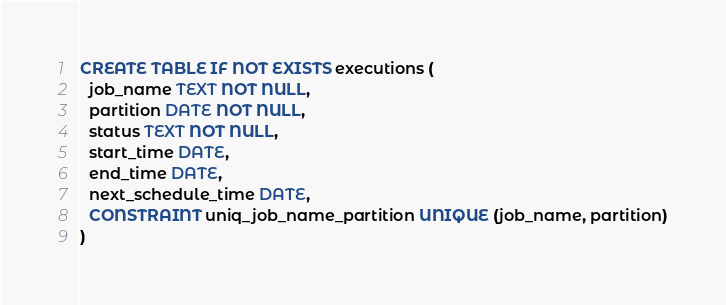Convert code to text. <code><loc_0><loc_0><loc_500><loc_500><_SQL_>CREATE TABLE IF NOT EXISTS executions (
  job_name TEXT NOT NULL,
  partition DATE NOT NULL,
  status TEXT NOT NULL,
  start_time DATE,
  end_time DATE,
  next_schedule_time DATE,
  CONSTRAINT uniq_job_name_partition UNIQUE (job_name, partition)
)</code> 